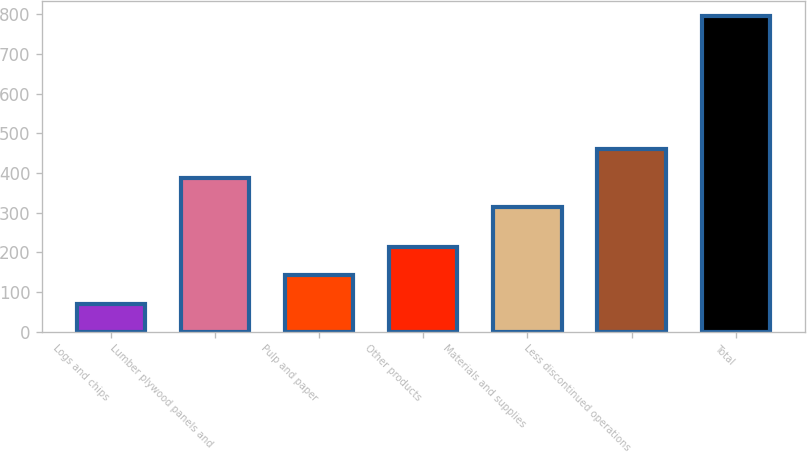<chart> <loc_0><loc_0><loc_500><loc_500><bar_chart><fcel>Logs and chips<fcel>Lumber plywood panels and<fcel>Pulp and paper<fcel>Other products<fcel>Materials and supplies<fcel>Less discontinued operations<fcel>Total<nl><fcel>69<fcel>387.6<fcel>141.6<fcel>214.2<fcel>315<fcel>460.2<fcel>795<nl></chart> 